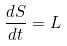Convert formula to latex. <formula><loc_0><loc_0><loc_500><loc_500>\frac { d S } { d t } = L</formula> 